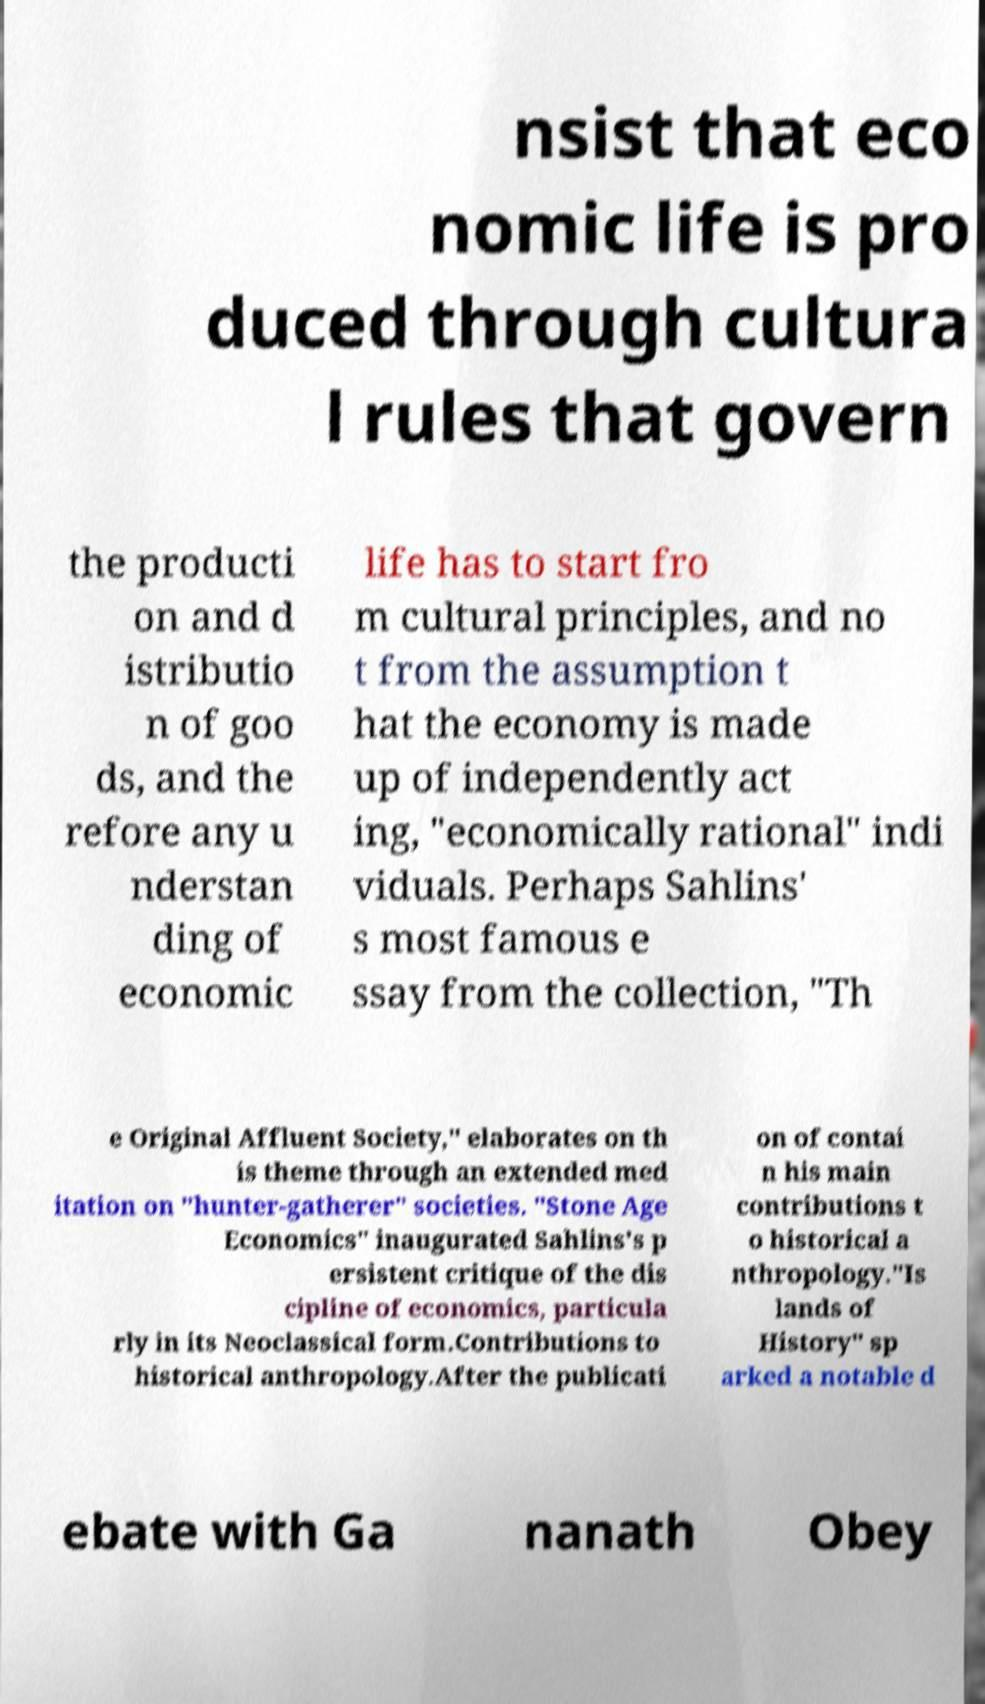I need the written content from this picture converted into text. Can you do that? nsist that eco nomic life is pro duced through cultura l rules that govern the producti on and d istributio n of goo ds, and the refore any u nderstan ding of economic life has to start fro m cultural principles, and no t from the assumption t hat the economy is made up of independently act ing, "economically rational" indi viduals. Perhaps Sahlins' s most famous e ssay from the collection, "Th e Original Affluent Society," elaborates on th is theme through an extended med itation on "hunter-gatherer" societies. "Stone Age Economics" inaugurated Sahlins's p ersistent critique of the dis cipline of economics, particula rly in its Neoclassical form.Contributions to historical anthropology.After the publicati on of contai n his main contributions t o historical a nthropology."Is lands of History" sp arked a notable d ebate with Ga nanath Obey 